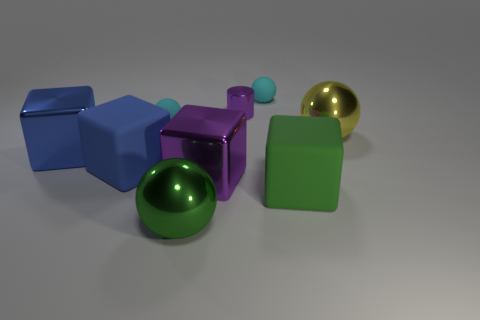Are there more large rubber objects that are right of the purple metallic cube than purple cylinders that are right of the tiny purple cylinder?
Offer a very short reply. Yes. What number of blocks are the same color as the small cylinder?
Offer a terse response. 1. Is there anything else that is the same shape as the tiny purple object?
Make the answer very short. No. There is a purple metal object that is the same size as the blue metallic thing; what is its shape?
Your answer should be compact. Cube. What is the shape of the big thing that is on the left side of the big green shiny sphere and on the right side of the large blue metallic cube?
Give a very brief answer. Cube. What color is the other big cube that is made of the same material as the purple cube?
Offer a terse response. Blue. What is the size of the matte thing that is both left of the tiny purple metal object and right of the blue matte cube?
Give a very brief answer. Small. What material is the thing that is the same color as the metallic cylinder?
Provide a succinct answer. Metal. Are there the same number of tiny purple shiny cylinders in front of the large yellow metal object and large green rubber blocks?
Keep it short and to the point. No. Is the size of the green shiny sphere the same as the blue metal thing?
Your response must be concise. Yes. 